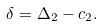Convert formula to latex. <formula><loc_0><loc_0><loc_500><loc_500>\delta = \Delta _ { 2 } - c _ { 2 } .</formula> 